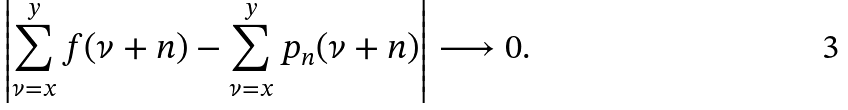Convert formula to latex. <formula><loc_0><loc_0><loc_500><loc_500>\left | \sum _ { \nu = x } ^ { y } f ( \nu + n ) - \sum _ { \nu = x } ^ { y } p _ { n } ( \nu + n ) \right | \longrightarrow 0 .</formula> 